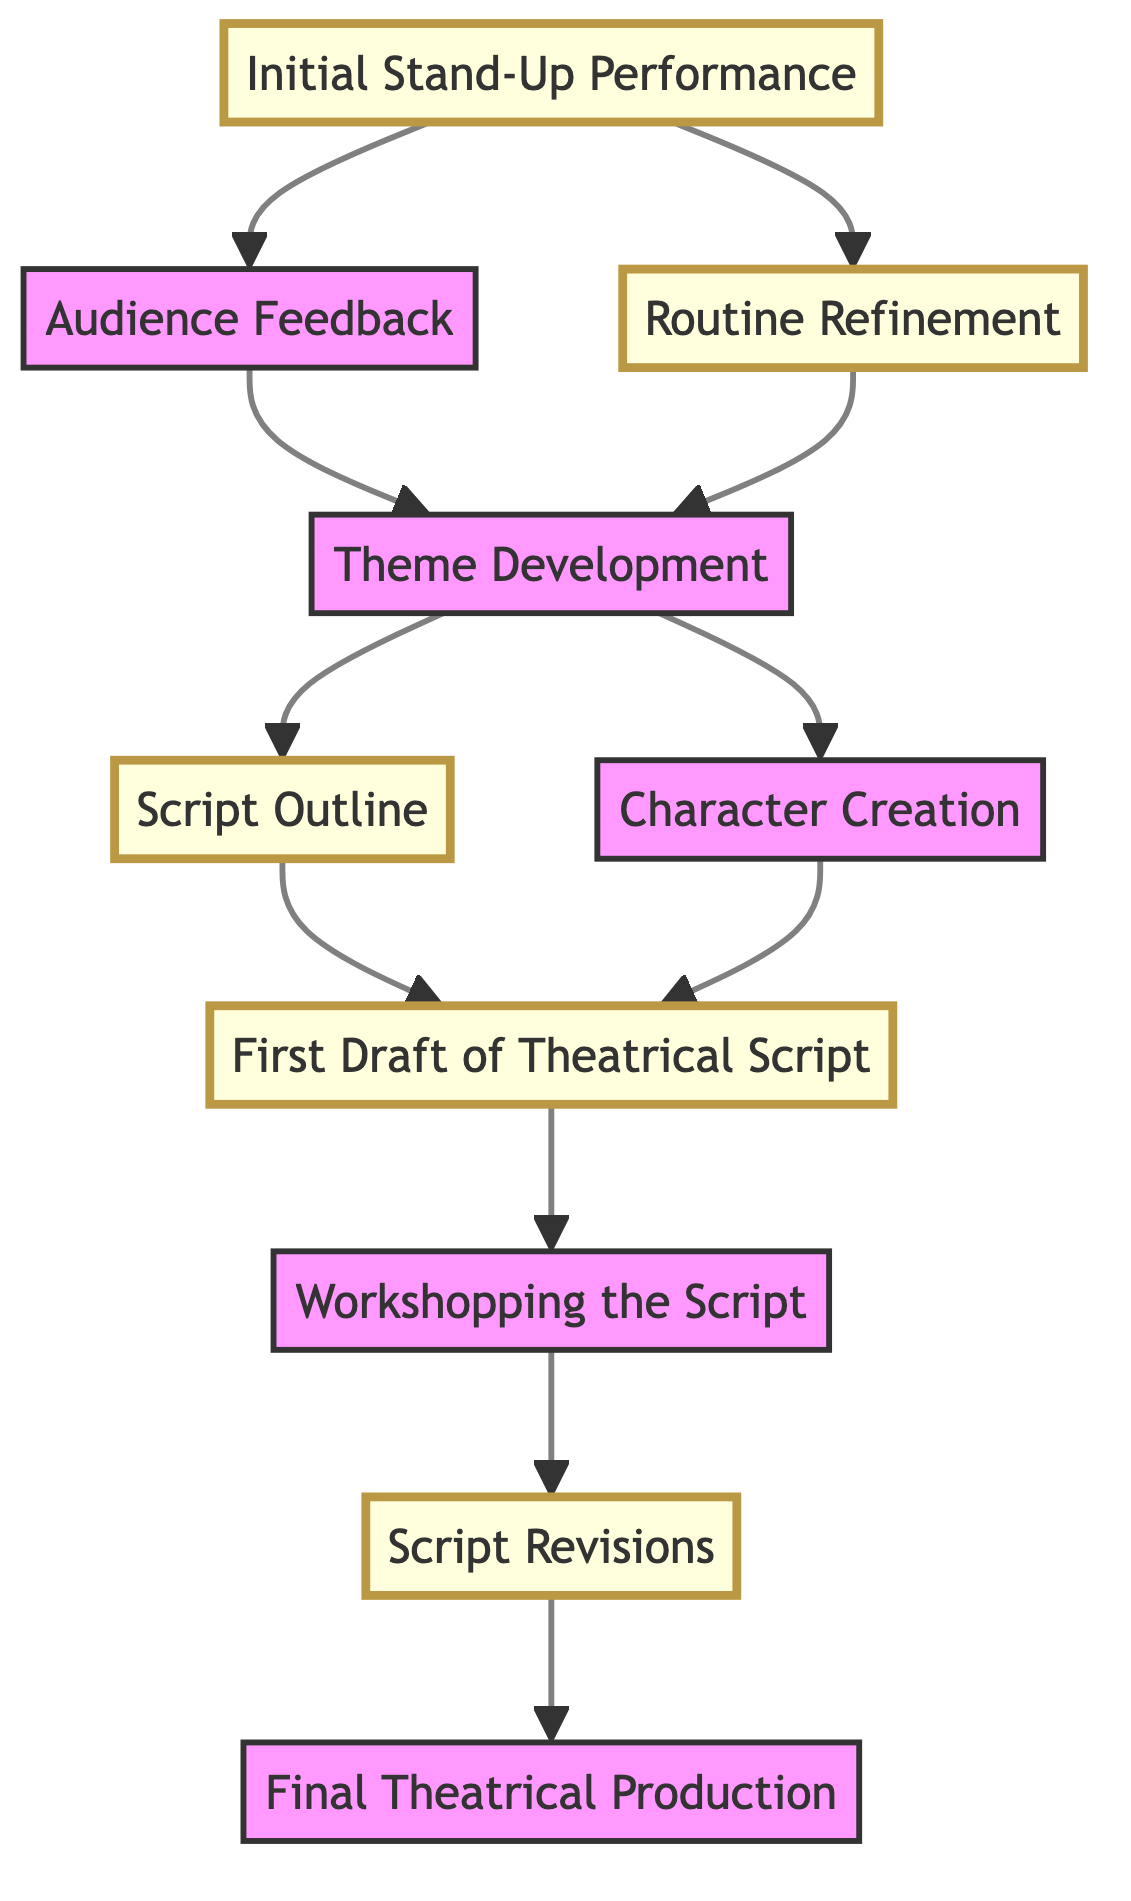What is the first step in the diagram? The first step in the diagram is labeled as "Initial Stand-Up Performance." It is the starting point from which all other stages develop in the evolution of the stand-up routine to a theatrical script.
Answer: Initial Stand-Up Performance How many nodes are there in total? Counting all the elements listed in the diagram, there are ten nodes that represent different stages in the evolution process.
Answer: 10 What follows after "Audience Feedback"? After "Audience Feedback," the next stage in the diagram is "Theme Development." It indicates that audience reactions contribute to the development of the central themes and narratives for the script.
Answer: Theme Development Which node connects to both "Script Outline" and "Character Creation"? The node that connects to both "Script Outline" and "Character Creation" is "Theme Development." This node indicates that themes help in guiding the creation of both the script's structure and its characters.
Answer: Theme Development What is the final output according to the diagram? The final output indicated in the diagram is "Final Theatrical Production." This is the conclusion of the entire process of transforming a stand-up routine into a theatrical play.
Answer: Final Theatrical Production If you start at "Initial Stand-Up Performance," which node would you reach after one more stage? Starting from "Initial Stand-Up Performance," if you go to "Audience Feedback" or "Routine Refinement" next, after that step, the only option you have is to proceed to "Theme Development." So, one more stage leads you to "Theme Development."
Answer: Theme Development What are the two primary outputs of "Theme Development"? The two primary outputs of "Theme Development" are "Script Outline" and "Character Creation." This shows how identifying themes directly influences both the overall script and the characters involved in it.
Answer: Script Outline and Character Creation Which steps involve revisions in the diagram? The steps that involve revisions are "Routine Refinement" and "Script Revisions." Both stages indicate a process of taking feedback and improving the output based on it.
Answer: Routine Refinement and Script Revisions 